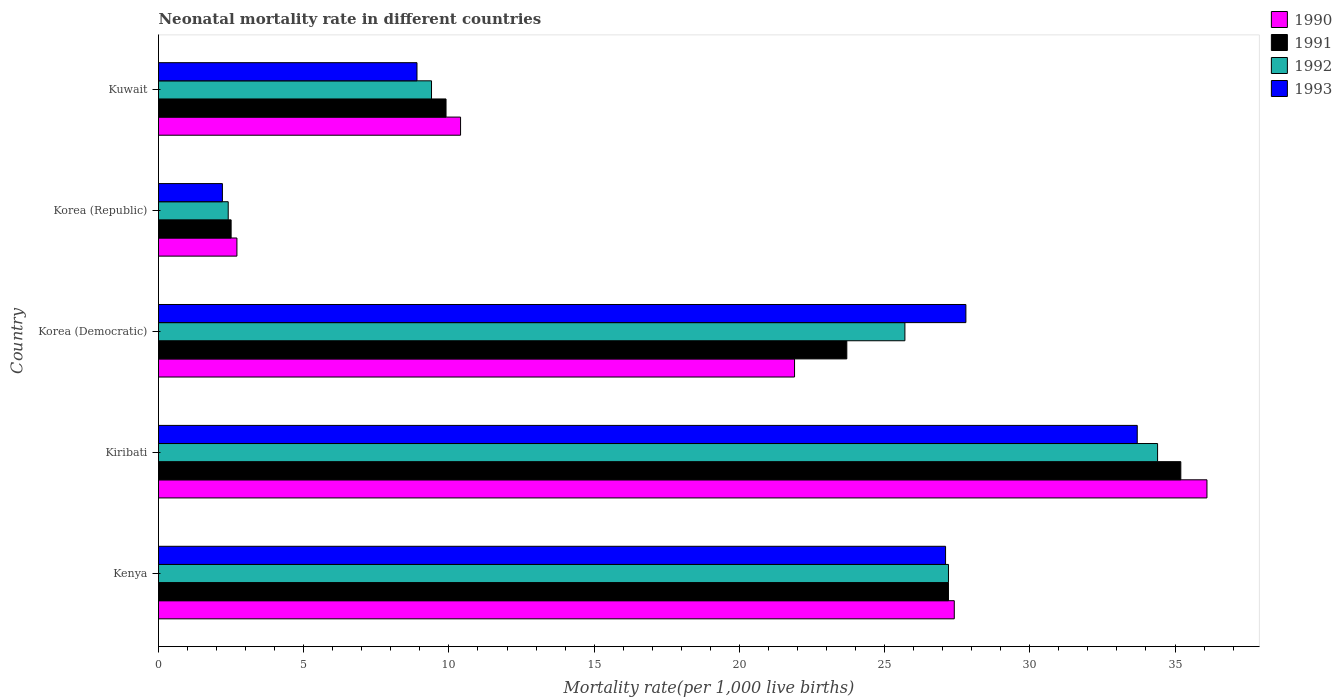Are the number of bars per tick equal to the number of legend labels?
Offer a very short reply. Yes. Are the number of bars on each tick of the Y-axis equal?
Offer a terse response. Yes. How many bars are there on the 3rd tick from the bottom?
Ensure brevity in your answer.  4. What is the label of the 4th group of bars from the top?
Provide a short and direct response. Kiribati. In how many cases, is the number of bars for a given country not equal to the number of legend labels?
Provide a succinct answer. 0. What is the neonatal mortality rate in 1991 in Korea (Democratic)?
Give a very brief answer. 23.7. Across all countries, what is the maximum neonatal mortality rate in 1991?
Ensure brevity in your answer.  35.2. In which country was the neonatal mortality rate in 1993 maximum?
Your answer should be compact. Kiribati. What is the total neonatal mortality rate in 1991 in the graph?
Give a very brief answer. 98.5. What is the difference between the neonatal mortality rate in 1993 in Kenya and that in Kuwait?
Give a very brief answer. 18.2. What is the difference between the neonatal mortality rate in 1992 in Kuwait and the neonatal mortality rate in 1990 in Kiribati?
Your answer should be very brief. -26.7. What is the average neonatal mortality rate in 1991 per country?
Your answer should be very brief. 19.7. What is the difference between the neonatal mortality rate in 1990 and neonatal mortality rate in 1992 in Korea (Republic)?
Your response must be concise. 0.3. In how many countries, is the neonatal mortality rate in 1991 greater than 29 ?
Make the answer very short. 1. What is the ratio of the neonatal mortality rate in 1992 in Korea (Democratic) to that in Kuwait?
Provide a short and direct response. 2.73. Is the neonatal mortality rate in 1991 in Korea (Democratic) less than that in Kuwait?
Offer a very short reply. No. What is the difference between the highest and the second highest neonatal mortality rate in 1991?
Make the answer very short. 8. What is the difference between the highest and the lowest neonatal mortality rate in 1990?
Your response must be concise. 33.4. Is the sum of the neonatal mortality rate in 1993 in Korea (Democratic) and Kuwait greater than the maximum neonatal mortality rate in 1992 across all countries?
Provide a short and direct response. Yes. What does the 2nd bar from the top in Kuwait represents?
Provide a succinct answer. 1992. What does the 1st bar from the bottom in Korea (Republic) represents?
Give a very brief answer. 1990. How many bars are there?
Your response must be concise. 20. Are all the bars in the graph horizontal?
Offer a terse response. Yes. What is the difference between two consecutive major ticks on the X-axis?
Your answer should be compact. 5. Are the values on the major ticks of X-axis written in scientific E-notation?
Provide a succinct answer. No. Does the graph contain any zero values?
Keep it short and to the point. No. Does the graph contain grids?
Make the answer very short. No. What is the title of the graph?
Keep it short and to the point. Neonatal mortality rate in different countries. Does "2001" appear as one of the legend labels in the graph?
Give a very brief answer. No. What is the label or title of the X-axis?
Offer a very short reply. Mortality rate(per 1,0 live births). What is the Mortality rate(per 1,000 live births) in 1990 in Kenya?
Keep it short and to the point. 27.4. What is the Mortality rate(per 1,000 live births) in 1991 in Kenya?
Provide a succinct answer. 27.2. What is the Mortality rate(per 1,000 live births) in 1992 in Kenya?
Ensure brevity in your answer.  27.2. What is the Mortality rate(per 1,000 live births) of 1993 in Kenya?
Offer a terse response. 27.1. What is the Mortality rate(per 1,000 live births) in 1990 in Kiribati?
Provide a short and direct response. 36.1. What is the Mortality rate(per 1,000 live births) of 1991 in Kiribati?
Give a very brief answer. 35.2. What is the Mortality rate(per 1,000 live births) of 1992 in Kiribati?
Your answer should be compact. 34.4. What is the Mortality rate(per 1,000 live births) in 1993 in Kiribati?
Keep it short and to the point. 33.7. What is the Mortality rate(per 1,000 live births) in 1990 in Korea (Democratic)?
Your answer should be compact. 21.9. What is the Mortality rate(per 1,000 live births) in 1991 in Korea (Democratic)?
Provide a short and direct response. 23.7. What is the Mortality rate(per 1,000 live births) in 1992 in Korea (Democratic)?
Offer a terse response. 25.7. What is the Mortality rate(per 1,000 live births) of 1993 in Korea (Democratic)?
Make the answer very short. 27.8. What is the Mortality rate(per 1,000 live births) of 1991 in Korea (Republic)?
Give a very brief answer. 2.5. What is the Mortality rate(per 1,000 live births) of 1993 in Korea (Republic)?
Offer a terse response. 2.2. What is the Mortality rate(per 1,000 live births) in 1991 in Kuwait?
Give a very brief answer. 9.9. Across all countries, what is the maximum Mortality rate(per 1,000 live births) in 1990?
Ensure brevity in your answer.  36.1. Across all countries, what is the maximum Mortality rate(per 1,000 live births) of 1991?
Ensure brevity in your answer.  35.2. Across all countries, what is the maximum Mortality rate(per 1,000 live births) in 1992?
Ensure brevity in your answer.  34.4. Across all countries, what is the maximum Mortality rate(per 1,000 live births) in 1993?
Make the answer very short. 33.7. Across all countries, what is the minimum Mortality rate(per 1,000 live births) of 1993?
Your response must be concise. 2.2. What is the total Mortality rate(per 1,000 live births) of 1990 in the graph?
Your response must be concise. 98.5. What is the total Mortality rate(per 1,000 live births) of 1991 in the graph?
Ensure brevity in your answer.  98.5. What is the total Mortality rate(per 1,000 live births) in 1992 in the graph?
Your answer should be very brief. 99.1. What is the total Mortality rate(per 1,000 live births) of 1993 in the graph?
Your answer should be compact. 99.7. What is the difference between the Mortality rate(per 1,000 live births) of 1991 in Kenya and that in Kiribati?
Provide a succinct answer. -8. What is the difference between the Mortality rate(per 1,000 live births) of 1992 in Kenya and that in Kiribati?
Your response must be concise. -7.2. What is the difference between the Mortality rate(per 1,000 live births) of 1990 in Kenya and that in Korea (Democratic)?
Offer a terse response. 5.5. What is the difference between the Mortality rate(per 1,000 live births) of 1992 in Kenya and that in Korea (Democratic)?
Give a very brief answer. 1.5. What is the difference between the Mortality rate(per 1,000 live births) of 1993 in Kenya and that in Korea (Democratic)?
Provide a succinct answer. -0.7. What is the difference between the Mortality rate(per 1,000 live births) in 1990 in Kenya and that in Korea (Republic)?
Offer a very short reply. 24.7. What is the difference between the Mortality rate(per 1,000 live births) of 1991 in Kenya and that in Korea (Republic)?
Your answer should be very brief. 24.7. What is the difference between the Mortality rate(per 1,000 live births) in 1992 in Kenya and that in Korea (Republic)?
Keep it short and to the point. 24.8. What is the difference between the Mortality rate(per 1,000 live births) in 1993 in Kenya and that in Korea (Republic)?
Your response must be concise. 24.9. What is the difference between the Mortality rate(per 1,000 live births) of 1990 in Kenya and that in Kuwait?
Provide a short and direct response. 17. What is the difference between the Mortality rate(per 1,000 live births) in 1992 in Kenya and that in Kuwait?
Your answer should be very brief. 17.8. What is the difference between the Mortality rate(per 1,000 live births) in 1993 in Kenya and that in Kuwait?
Provide a succinct answer. 18.2. What is the difference between the Mortality rate(per 1,000 live births) of 1992 in Kiribati and that in Korea (Democratic)?
Your answer should be compact. 8.7. What is the difference between the Mortality rate(per 1,000 live births) of 1993 in Kiribati and that in Korea (Democratic)?
Give a very brief answer. 5.9. What is the difference between the Mortality rate(per 1,000 live births) of 1990 in Kiribati and that in Korea (Republic)?
Your answer should be very brief. 33.4. What is the difference between the Mortality rate(per 1,000 live births) of 1991 in Kiribati and that in Korea (Republic)?
Ensure brevity in your answer.  32.7. What is the difference between the Mortality rate(per 1,000 live births) in 1993 in Kiribati and that in Korea (Republic)?
Give a very brief answer. 31.5. What is the difference between the Mortality rate(per 1,000 live births) in 1990 in Kiribati and that in Kuwait?
Ensure brevity in your answer.  25.7. What is the difference between the Mortality rate(per 1,000 live births) in 1991 in Kiribati and that in Kuwait?
Offer a terse response. 25.3. What is the difference between the Mortality rate(per 1,000 live births) of 1992 in Kiribati and that in Kuwait?
Make the answer very short. 25. What is the difference between the Mortality rate(per 1,000 live births) of 1993 in Kiribati and that in Kuwait?
Make the answer very short. 24.8. What is the difference between the Mortality rate(per 1,000 live births) of 1991 in Korea (Democratic) and that in Korea (Republic)?
Your response must be concise. 21.2. What is the difference between the Mortality rate(per 1,000 live births) of 1992 in Korea (Democratic) and that in Korea (Republic)?
Your answer should be compact. 23.3. What is the difference between the Mortality rate(per 1,000 live births) of 1993 in Korea (Democratic) and that in Korea (Republic)?
Give a very brief answer. 25.6. What is the difference between the Mortality rate(per 1,000 live births) of 1990 in Korea (Democratic) and that in Kuwait?
Provide a succinct answer. 11.5. What is the difference between the Mortality rate(per 1,000 live births) of 1991 in Korea (Democratic) and that in Kuwait?
Your answer should be very brief. 13.8. What is the difference between the Mortality rate(per 1,000 live births) in 1992 in Korea (Democratic) and that in Kuwait?
Keep it short and to the point. 16.3. What is the difference between the Mortality rate(per 1,000 live births) in 1990 in Korea (Republic) and that in Kuwait?
Ensure brevity in your answer.  -7.7. What is the difference between the Mortality rate(per 1,000 live births) in 1993 in Korea (Republic) and that in Kuwait?
Offer a terse response. -6.7. What is the difference between the Mortality rate(per 1,000 live births) in 1990 in Kenya and the Mortality rate(per 1,000 live births) in 1991 in Kiribati?
Ensure brevity in your answer.  -7.8. What is the difference between the Mortality rate(per 1,000 live births) in 1990 in Kenya and the Mortality rate(per 1,000 live births) in 1992 in Kiribati?
Offer a terse response. -7. What is the difference between the Mortality rate(per 1,000 live births) in 1991 in Kenya and the Mortality rate(per 1,000 live births) in 1993 in Kiribati?
Make the answer very short. -6.5. What is the difference between the Mortality rate(per 1,000 live births) in 1992 in Kenya and the Mortality rate(per 1,000 live births) in 1993 in Kiribati?
Your response must be concise. -6.5. What is the difference between the Mortality rate(per 1,000 live births) in 1990 in Kenya and the Mortality rate(per 1,000 live births) in 1991 in Korea (Democratic)?
Ensure brevity in your answer.  3.7. What is the difference between the Mortality rate(per 1,000 live births) in 1990 in Kenya and the Mortality rate(per 1,000 live births) in 1992 in Korea (Democratic)?
Your answer should be very brief. 1.7. What is the difference between the Mortality rate(per 1,000 live births) of 1991 in Kenya and the Mortality rate(per 1,000 live births) of 1992 in Korea (Democratic)?
Offer a terse response. 1.5. What is the difference between the Mortality rate(per 1,000 live births) of 1991 in Kenya and the Mortality rate(per 1,000 live births) of 1993 in Korea (Democratic)?
Keep it short and to the point. -0.6. What is the difference between the Mortality rate(per 1,000 live births) in 1992 in Kenya and the Mortality rate(per 1,000 live births) in 1993 in Korea (Democratic)?
Your answer should be very brief. -0.6. What is the difference between the Mortality rate(per 1,000 live births) of 1990 in Kenya and the Mortality rate(per 1,000 live births) of 1991 in Korea (Republic)?
Your answer should be very brief. 24.9. What is the difference between the Mortality rate(per 1,000 live births) of 1990 in Kenya and the Mortality rate(per 1,000 live births) of 1993 in Korea (Republic)?
Give a very brief answer. 25.2. What is the difference between the Mortality rate(per 1,000 live births) of 1991 in Kenya and the Mortality rate(per 1,000 live births) of 1992 in Korea (Republic)?
Provide a short and direct response. 24.8. What is the difference between the Mortality rate(per 1,000 live births) in 1991 in Kenya and the Mortality rate(per 1,000 live births) in 1993 in Korea (Republic)?
Give a very brief answer. 25. What is the difference between the Mortality rate(per 1,000 live births) in 1990 in Kenya and the Mortality rate(per 1,000 live births) in 1992 in Kuwait?
Give a very brief answer. 18. What is the difference between the Mortality rate(per 1,000 live births) of 1991 in Kenya and the Mortality rate(per 1,000 live births) of 1992 in Kuwait?
Offer a terse response. 17.8. What is the difference between the Mortality rate(per 1,000 live births) in 1992 in Kenya and the Mortality rate(per 1,000 live births) in 1993 in Kuwait?
Ensure brevity in your answer.  18.3. What is the difference between the Mortality rate(per 1,000 live births) in 1990 in Kiribati and the Mortality rate(per 1,000 live births) in 1992 in Korea (Democratic)?
Make the answer very short. 10.4. What is the difference between the Mortality rate(per 1,000 live births) in 1990 in Kiribati and the Mortality rate(per 1,000 live births) in 1993 in Korea (Democratic)?
Provide a short and direct response. 8.3. What is the difference between the Mortality rate(per 1,000 live births) in 1991 in Kiribati and the Mortality rate(per 1,000 live births) in 1993 in Korea (Democratic)?
Offer a terse response. 7.4. What is the difference between the Mortality rate(per 1,000 live births) of 1990 in Kiribati and the Mortality rate(per 1,000 live births) of 1991 in Korea (Republic)?
Your response must be concise. 33.6. What is the difference between the Mortality rate(per 1,000 live births) in 1990 in Kiribati and the Mortality rate(per 1,000 live births) in 1992 in Korea (Republic)?
Make the answer very short. 33.7. What is the difference between the Mortality rate(per 1,000 live births) of 1990 in Kiribati and the Mortality rate(per 1,000 live births) of 1993 in Korea (Republic)?
Your answer should be very brief. 33.9. What is the difference between the Mortality rate(per 1,000 live births) of 1991 in Kiribati and the Mortality rate(per 1,000 live births) of 1992 in Korea (Republic)?
Offer a very short reply. 32.8. What is the difference between the Mortality rate(per 1,000 live births) in 1991 in Kiribati and the Mortality rate(per 1,000 live births) in 1993 in Korea (Republic)?
Your answer should be compact. 33. What is the difference between the Mortality rate(per 1,000 live births) in 1992 in Kiribati and the Mortality rate(per 1,000 live births) in 1993 in Korea (Republic)?
Ensure brevity in your answer.  32.2. What is the difference between the Mortality rate(per 1,000 live births) of 1990 in Kiribati and the Mortality rate(per 1,000 live births) of 1991 in Kuwait?
Provide a short and direct response. 26.2. What is the difference between the Mortality rate(per 1,000 live births) in 1990 in Kiribati and the Mortality rate(per 1,000 live births) in 1992 in Kuwait?
Keep it short and to the point. 26.7. What is the difference between the Mortality rate(per 1,000 live births) of 1990 in Kiribati and the Mortality rate(per 1,000 live births) of 1993 in Kuwait?
Make the answer very short. 27.2. What is the difference between the Mortality rate(per 1,000 live births) in 1991 in Kiribati and the Mortality rate(per 1,000 live births) in 1992 in Kuwait?
Keep it short and to the point. 25.8. What is the difference between the Mortality rate(per 1,000 live births) in 1991 in Kiribati and the Mortality rate(per 1,000 live births) in 1993 in Kuwait?
Keep it short and to the point. 26.3. What is the difference between the Mortality rate(per 1,000 live births) in 1990 in Korea (Democratic) and the Mortality rate(per 1,000 live births) in 1992 in Korea (Republic)?
Make the answer very short. 19.5. What is the difference between the Mortality rate(per 1,000 live births) of 1990 in Korea (Democratic) and the Mortality rate(per 1,000 live births) of 1993 in Korea (Republic)?
Give a very brief answer. 19.7. What is the difference between the Mortality rate(per 1,000 live births) in 1991 in Korea (Democratic) and the Mortality rate(per 1,000 live births) in 1992 in Korea (Republic)?
Provide a short and direct response. 21.3. What is the difference between the Mortality rate(per 1,000 live births) of 1991 in Korea (Democratic) and the Mortality rate(per 1,000 live births) of 1993 in Korea (Republic)?
Your response must be concise. 21.5. What is the difference between the Mortality rate(per 1,000 live births) of 1990 in Korea (Democratic) and the Mortality rate(per 1,000 live births) of 1991 in Kuwait?
Your response must be concise. 12. What is the difference between the Mortality rate(per 1,000 live births) of 1991 in Korea (Democratic) and the Mortality rate(per 1,000 live births) of 1992 in Kuwait?
Your answer should be very brief. 14.3. What is the difference between the Mortality rate(per 1,000 live births) of 1990 in Korea (Republic) and the Mortality rate(per 1,000 live births) of 1993 in Kuwait?
Give a very brief answer. -6.2. What is the difference between the Mortality rate(per 1,000 live births) of 1991 in Korea (Republic) and the Mortality rate(per 1,000 live births) of 1992 in Kuwait?
Keep it short and to the point. -6.9. What is the difference between the Mortality rate(per 1,000 live births) of 1991 in Korea (Republic) and the Mortality rate(per 1,000 live births) of 1993 in Kuwait?
Offer a terse response. -6.4. What is the difference between the Mortality rate(per 1,000 live births) of 1992 in Korea (Republic) and the Mortality rate(per 1,000 live births) of 1993 in Kuwait?
Give a very brief answer. -6.5. What is the average Mortality rate(per 1,000 live births) in 1992 per country?
Offer a terse response. 19.82. What is the average Mortality rate(per 1,000 live births) in 1993 per country?
Your answer should be compact. 19.94. What is the difference between the Mortality rate(per 1,000 live births) in 1990 and Mortality rate(per 1,000 live births) in 1992 in Kenya?
Your response must be concise. 0.2. What is the difference between the Mortality rate(per 1,000 live births) of 1991 and Mortality rate(per 1,000 live births) of 1992 in Kenya?
Keep it short and to the point. 0. What is the difference between the Mortality rate(per 1,000 live births) of 1991 and Mortality rate(per 1,000 live births) of 1993 in Kenya?
Make the answer very short. 0.1. What is the difference between the Mortality rate(per 1,000 live births) of 1990 and Mortality rate(per 1,000 live births) of 1992 in Kiribati?
Your answer should be very brief. 1.7. What is the difference between the Mortality rate(per 1,000 live births) of 1990 and Mortality rate(per 1,000 live births) of 1993 in Kiribati?
Provide a short and direct response. 2.4. What is the difference between the Mortality rate(per 1,000 live births) in 1991 and Mortality rate(per 1,000 live births) in 1993 in Kiribati?
Offer a terse response. 1.5. What is the difference between the Mortality rate(per 1,000 live births) in 1990 and Mortality rate(per 1,000 live births) in 1991 in Korea (Democratic)?
Provide a succinct answer. -1.8. What is the difference between the Mortality rate(per 1,000 live births) in 1992 and Mortality rate(per 1,000 live births) in 1993 in Korea (Democratic)?
Provide a succinct answer. -2.1. What is the difference between the Mortality rate(per 1,000 live births) of 1990 and Mortality rate(per 1,000 live births) of 1991 in Korea (Republic)?
Your answer should be compact. 0.2. What is the difference between the Mortality rate(per 1,000 live births) in 1990 and Mortality rate(per 1,000 live births) in 1992 in Korea (Republic)?
Your answer should be compact. 0.3. What is the difference between the Mortality rate(per 1,000 live births) of 1990 and Mortality rate(per 1,000 live births) of 1993 in Korea (Republic)?
Give a very brief answer. 0.5. What is the difference between the Mortality rate(per 1,000 live births) in 1992 and Mortality rate(per 1,000 live births) in 1993 in Korea (Republic)?
Your answer should be very brief. 0.2. What is the difference between the Mortality rate(per 1,000 live births) in 1991 and Mortality rate(per 1,000 live births) in 1993 in Kuwait?
Keep it short and to the point. 1. What is the ratio of the Mortality rate(per 1,000 live births) of 1990 in Kenya to that in Kiribati?
Make the answer very short. 0.76. What is the ratio of the Mortality rate(per 1,000 live births) of 1991 in Kenya to that in Kiribati?
Keep it short and to the point. 0.77. What is the ratio of the Mortality rate(per 1,000 live births) in 1992 in Kenya to that in Kiribati?
Offer a very short reply. 0.79. What is the ratio of the Mortality rate(per 1,000 live births) of 1993 in Kenya to that in Kiribati?
Provide a short and direct response. 0.8. What is the ratio of the Mortality rate(per 1,000 live births) of 1990 in Kenya to that in Korea (Democratic)?
Ensure brevity in your answer.  1.25. What is the ratio of the Mortality rate(per 1,000 live births) in 1991 in Kenya to that in Korea (Democratic)?
Offer a very short reply. 1.15. What is the ratio of the Mortality rate(per 1,000 live births) in 1992 in Kenya to that in Korea (Democratic)?
Your answer should be compact. 1.06. What is the ratio of the Mortality rate(per 1,000 live births) in 1993 in Kenya to that in Korea (Democratic)?
Keep it short and to the point. 0.97. What is the ratio of the Mortality rate(per 1,000 live births) in 1990 in Kenya to that in Korea (Republic)?
Offer a terse response. 10.15. What is the ratio of the Mortality rate(per 1,000 live births) of 1991 in Kenya to that in Korea (Republic)?
Your answer should be very brief. 10.88. What is the ratio of the Mortality rate(per 1,000 live births) in 1992 in Kenya to that in Korea (Republic)?
Offer a very short reply. 11.33. What is the ratio of the Mortality rate(per 1,000 live births) of 1993 in Kenya to that in Korea (Republic)?
Give a very brief answer. 12.32. What is the ratio of the Mortality rate(per 1,000 live births) of 1990 in Kenya to that in Kuwait?
Offer a terse response. 2.63. What is the ratio of the Mortality rate(per 1,000 live births) of 1991 in Kenya to that in Kuwait?
Make the answer very short. 2.75. What is the ratio of the Mortality rate(per 1,000 live births) of 1992 in Kenya to that in Kuwait?
Keep it short and to the point. 2.89. What is the ratio of the Mortality rate(per 1,000 live births) in 1993 in Kenya to that in Kuwait?
Give a very brief answer. 3.04. What is the ratio of the Mortality rate(per 1,000 live births) of 1990 in Kiribati to that in Korea (Democratic)?
Your answer should be compact. 1.65. What is the ratio of the Mortality rate(per 1,000 live births) of 1991 in Kiribati to that in Korea (Democratic)?
Provide a succinct answer. 1.49. What is the ratio of the Mortality rate(per 1,000 live births) of 1992 in Kiribati to that in Korea (Democratic)?
Provide a succinct answer. 1.34. What is the ratio of the Mortality rate(per 1,000 live births) in 1993 in Kiribati to that in Korea (Democratic)?
Keep it short and to the point. 1.21. What is the ratio of the Mortality rate(per 1,000 live births) in 1990 in Kiribati to that in Korea (Republic)?
Provide a short and direct response. 13.37. What is the ratio of the Mortality rate(per 1,000 live births) in 1991 in Kiribati to that in Korea (Republic)?
Give a very brief answer. 14.08. What is the ratio of the Mortality rate(per 1,000 live births) of 1992 in Kiribati to that in Korea (Republic)?
Give a very brief answer. 14.33. What is the ratio of the Mortality rate(per 1,000 live births) in 1993 in Kiribati to that in Korea (Republic)?
Offer a terse response. 15.32. What is the ratio of the Mortality rate(per 1,000 live births) of 1990 in Kiribati to that in Kuwait?
Your answer should be very brief. 3.47. What is the ratio of the Mortality rate(per 1,000 live births) of 1991 in Kiribati to that in Kuwait?
Provide a succinct answer. 3.56. What is the ratio of the Mortality rate(per 1,000 live births) in 1992 in Kiribati to that in Kuwait?
Offer a very short reply. 3.66. What is the ratio of the Mortality rate(per 1,000 live births) of 1993 in Kiribati to that in Kuwait?
Make the answer very short. 3.79. What is the ratio of the Mortality rate(per 1,000 live births) in 1990 in Korea (Democratic) to that in Korea (Republic)?
Offer a very short reply. 8.11. What is the ratio of the Mortality rate(per 1,000 live births) of 1991 in Korea (Democratic) to that in Korea (Republic)?
Provide a short and direct response. 9.48. What is the ratio of the Mortality rate(per 1,000 live births) of 1992 in Korea (Democratic) to that in Korea (Republic)?
Give a very brief answer. 10.71. What is the ratio of the Mortality rate(per 1,000 live births) of 1993 in Korea (Democratic) to that in Korea (Republic)?
Provide a succinct answer. 12.64. What is the ratio of the Mortality rate(per 1,000 live births) of 1990 in Korea (Democratic) to that in Kuwait?
Your answer should be very brief. 2.11. What is the ratio of the Mortality rate(per 1,000 live births) of 1991 in Korea (Democratic) to that in Kuwait?
Your answer should be very brief. 2.39. What is the ratio of the Mortality rate(per 1,000 live births) of 1992 in Korea (Democratic) to that in Kuwait?
Your answer should be compact. 2.73. What is the ratio of the Mortality rate(per 1,000 live births) in 1993 in Korea (Democratic) to that in Kuwait?
Ensure brevity in your answer.  3.12. What is the ratio of the Mortality rate(per 1,000 live births) in 1990 in Korea (Republic) to that in Kuwait?
Your answer should be compact. 0.26. What is the ratio of the Mortality rate(per 1,000 live births) in 1991 in Korea (Republic) to that in Kuwait?
Keep it short and to the point. 0.25. What is the ratio of the Mortality rate(per 1,000 live births) in 1992 in Korea (Republic) to that in Kuwait?
Keep it short and to the point. 0.26. What is the ratio of the Mortality rate(per 1,000 live births) of 1993 in Korea (Republic) to that in Kuwait?
Make the answer very short. 0.25. What is the difference between the highest and the second highest Mortality rate(per 1,000 live births) of 1990?
Provide a short and direct response. 8.7. What is the difference between the highest and the second highest Mortality rate(per 1,000 live births) in 1992?
Offer a very short reply. 7.2. What is the difference between the highest and the second highest Mortality rate(per 1,000 live births) in 1993?
Your response must be concise. 5.9. What is the difference between the highest and the lowest Mortality rate(per 1,000 live births) of 1990?
Offer a terse response. 33.4. What is the difference between the highest and the lowest Mortality rate(per 1,000 live births) of 1991?
Provide a short and direct response. 32.7. What is the difference between the highest and the lowest Mortality rate(per 1,000 live births) in 1993?
Offer a terse response. 31.5. 